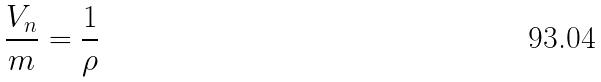<formula> <loc_0><loc_0><loc_500><loc_500>\frac { V _ { n } } { m } = \frac { 1 } { \rho }</formula> 